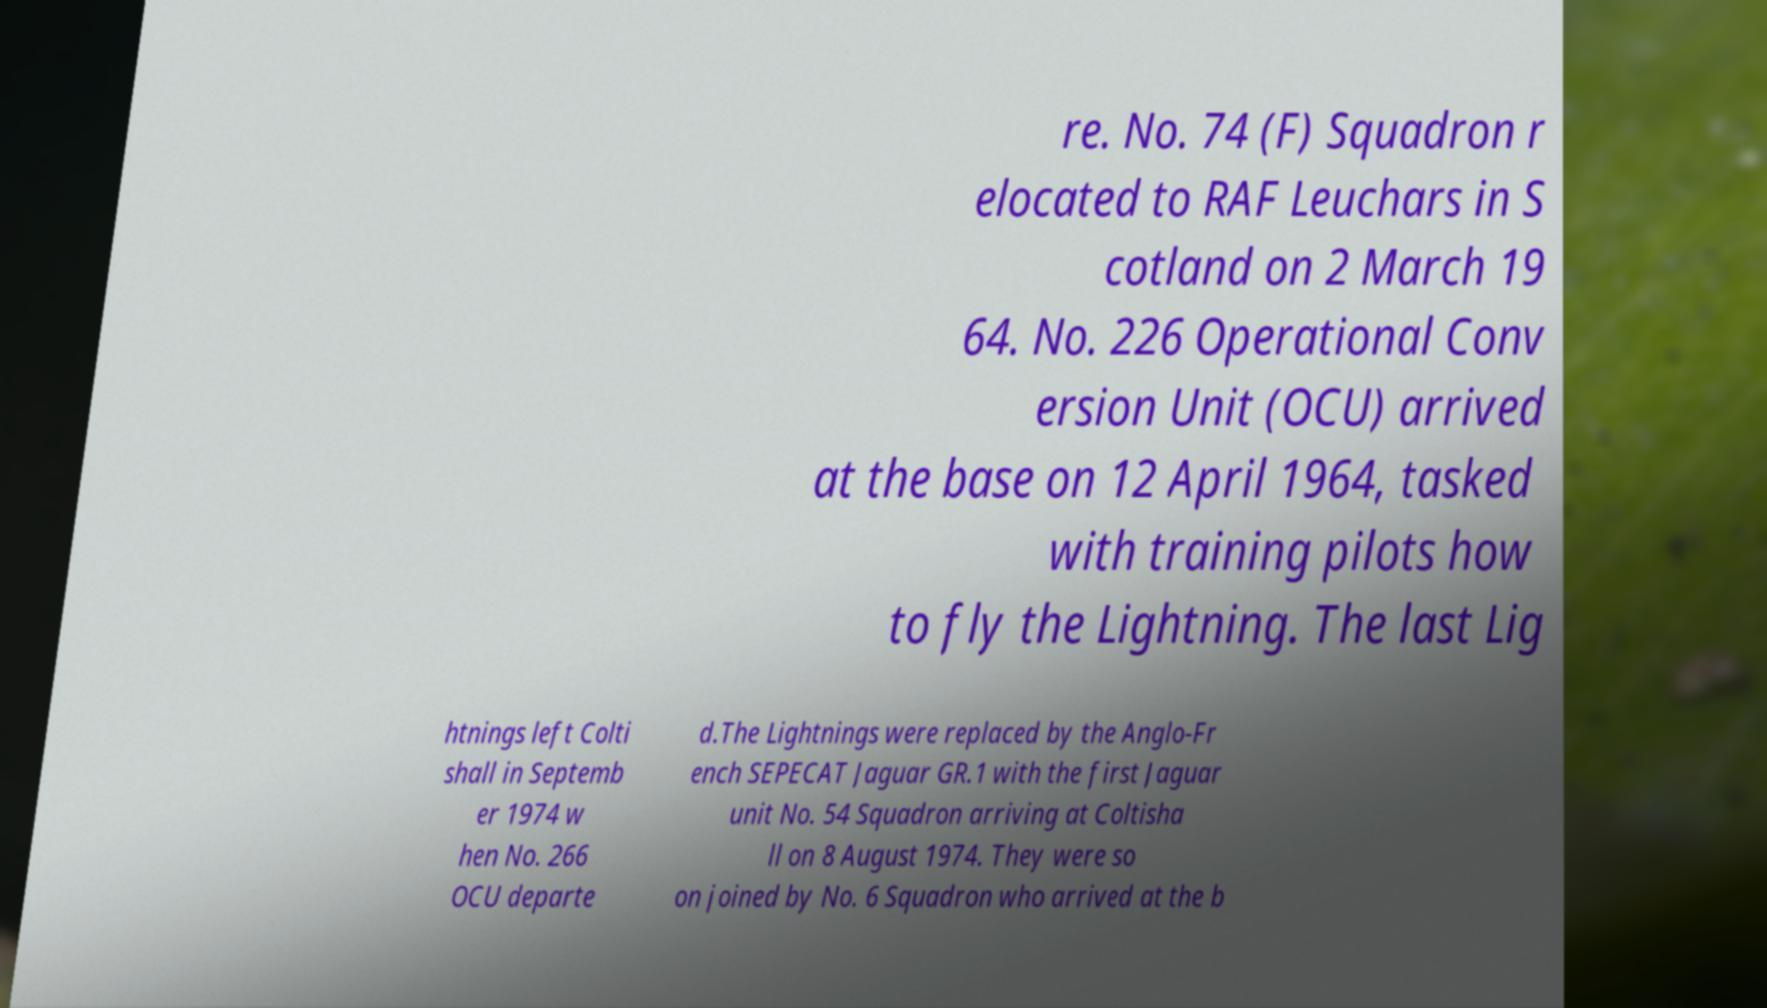Can you read and provide the text displayed in the image?This photo seems to have some interesting text. Can you extract and type it out for me? re. No. 74 (F) Squadron r elocated to RAF Leuchars in S cotland on 2 March 19 64. No. 226 Operational Conv ersion Unit (OCU) arrived at the base on 12 April 1964, tasked with training pilots how to fly the Lightning. The last Lig htnings left Colti shall in Septemb er 1974 w hen No. 266 OCU departe d.The Lightnings were replaced by the Anglo-Fr ench SEPECAT Jaguar GR.1 with the first Jaguar unit No. 54 Squadron arriving at Coltisha ll on 8 August 1974. They were so on joined by No. 6 Squadron who arrived at the b 